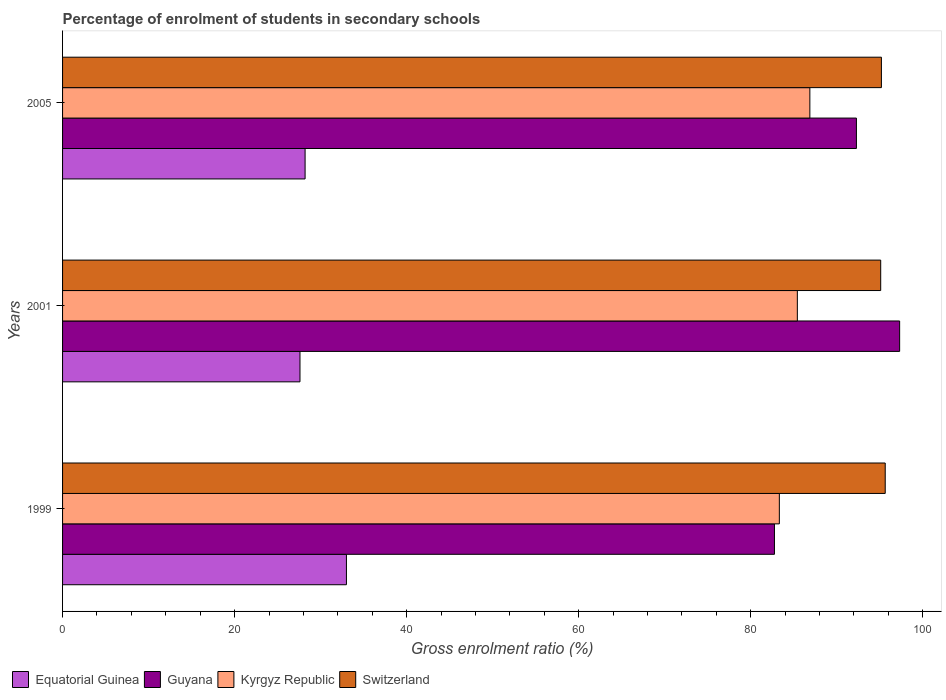How many different coloured bars are there?
Give a very brief answer. 4. Are the number of bars per tick equal to the number of legend labels?
Keep it short and to the point. Yes. Are the number of bars on each tick of the Y-axis equal?
Give a very brief answer. Yes. What is the label of the 1st group of bars from the top?
Ensure brevity in your answer.  2005. What is the percentage of students enrolled in secondary schools in Kyrgyz Republic in 2001?
Your response must be concise. 85.42. Across all years, what is the maximum percentage of students enrolled in secondary schools in Equatorial Guinea?
Offer a very short reply. 33. Across all years, what is the minimum percentage of students enrolled in secondary schools in Switzerland?
Keep it short and to the point. 95.11. In which year was the percentage of students enrolled in secondary schools in Switzerland minimum?
Provide a succinct answer. 2001. What is the total percentage of students enrolled in secondary schools in Guyana in the graph?
Your answer should be compact. 272.35. What is the difference between the percentage of students enrolled in secondary schools in Kyrgyz Republic in 2001 and that in 2005?
Provide a succinct answer. -1.46. What is the difference between the percentage of students enrolled in secondary schools in Switzerland in 2001 and the percentage of students enrolled in secondary schools in Kyrgyz Republic in 1999?
Your answer should be compact. 11.78. What is the average percentage of students enrolled in secondary schools in Switzerland per year?
Offer a very short reply. 95.31. In the year 2005, what is the difference between the percentage of students enrolled in secondary schools in Guyana and percentage of students enrolled in secondary schools in Equatorial Guinea?
Ensure brevity in your answer.  64.09. In how many years, is the percentage of students enrolled in secondary schools in Equatorial Guinea greater than 48 %?
Provide a short and direct response. 0. What is the ratio of the percentage of students enrolled in secondary schools in Equatorial Guinea in 2001 to that in 2005?
Provide a short and direct response. 0.98. Is the percentage of students enrolled in secondary schools in Kyrgyz Republic in 1999 less than that in 2005?
Offer a very short reply. Yes. What is the difference between the highest and the second highest percentage of students enrolled in secondary schools in Kyrgyz Republic?
Keep it short and to the point. 1.46. What is the difference between the highest and the lowest percentage of students enrolled in secondary schools in Switzerland?
Your answer should be compact. 0.53. What does the 3rd bar from the top in 1999 represents?
Provide a short and direct response. Guyana. What does the 2nd bar from the bottom in 2001 represents?
Your response must be concise. Guyana. Is it the case that in every year, the sum of the percentage of students enrolled in secondary schools in Equatorial Guinea and percentage of students enrolled in secondary schools in Guyana is greater than the percentage of students enrolled in secondary schools in Kyrgyz Republic?
Provide a succinct answer. Yes. How many years are there in the graph?
Keep it short and to the point. 3. What is the difference between two consecutive major ticks on the X-axis?
Offer a terse response. 20. Does the graph contain grids?
Your answer should be compact. No. How many legend labels are there?
Offer a very short reply. 4. How are the legend labels stacked?
Offer a terse response. Horizontal. What is the title of the graph?
Ensure brevity in your answer.  Percentage of enrolment of students in secondary schools. Does "Latin America(all income levels)" appear as one of the legend labels in the graph?
Ensure brevity in your answer.  No. What is the label or title of the X-axis?
Your response must be concise. Gross enrolment ratio (%). What is the label or title of the Y-axis?
Give a very brief answer. Years. What is the Gross enrolment ratio (%) of Equatorial Guinea in 1999?
Provide a succinct answer. 33. What is the Gross enrolment ratio (%) of Guyana in 1999?
Provide a succinct answer. 82.76. What is the Gross enrolment ratio (%) of Kyrgyz Republic in 1999?
Offer a very short reply. 83.33. What is the Gross enrolment ratio (%) in Switzerland in 1999?
Make the answer very short. 95.63. What is the Gross enrolment ratio (%) of Equatorial Guinea in 2001?
Provide a short and direct response. 27.6. What is the Gross enrolment ratio (%) in Guyana in 2001?
Provide a short and direct response. 97.31. What is the Gross enrolment ratio (%) in Kyrgyz Republic in 2001?
Offer a very short reply. 85.42. What is the Gross enrolment ratio (%) in Switzerland in 2001?
Offer a terse response. 95.11. What is the Gross enrolment ratio (%) of Equatorial Guinea in 2005?
Make the answer very short. 28.19. What is the Gross enrolment ratio (%) of Guyana in 2005?
Your answer should be very brief. 92.29. What is the Gross enrolment ratio (%) in Kyrgyz Republic in 2005?
Provide a succinct answer. 86.87. What is the Gross enrolment ratio (%) in Switzerland in 2005?
Make the answer very short. 95.19. Across all years, what is the maximum Gross enrolment ratio (%) in Equatorial Guinea?
Keep it short and to the point. 33. Across all years, what is the maximum Gross enrolment ratio (%) in Guyana?
Give a very brief answer. 97.31. Across all years, what is the maximum Gross enrolment ratio (%) in Kyrgyz Republic?
Provide a succinct answer. 86.87. Across all years, what is the maximum Gross enrolment ratio (%) of Switzerland?
Your answer should be very brief. 95.63. Across all years, what is the minimum Gross enrolment ratio (%) in Equatorial Guinea?
Give a very brief answer. 27.6. Across all years, what is the minimum Gross enrolment ratio (%) of Guyana?
Make the answer very short. 82.76. Across all years, what is the minimum Gross enrolment ratio (%) in Kyrgyz Republic?
Offer a terse response. 83.33. Across all years, what is the minimum Gross enrolment ratio (%) in Switzerland?
Offer a terse response. 95.11. What is the total Gross enrolment ratio (%) in Equatorial Guinea in the graph?
Give a very brief answer. 88.79. What is the total Gross enrolment ratio (%) in Guyana in the graph?
Offer a terse response. 272.35. What is the total Gross enrolment ratio (%) of Kyrgyz Republic in the graph?
Your answer should be very brief. 255.62. What is the total Gross enrolment ratio (%) in Switzerland in the graph?
Keep it short and to the point. 285.93. What is the difference between the Gross enrolment ratio (%) of Equatorial Guinea in 1999 and that in 2001?
Ensure brevity in your answer.  5.4. What is the difference between the Gross enrolment ratio (%) in Guyana in 1999 and that in 2001?
Offer a terse response. -14.55. What is the difference between the Gross enrolment ratio (%) of Kyrgyz Republic in 1999 and that in 2001?
Your response must be concise. -2.09. What is the difference between the Gross enrolment ratio (%) of Switzerland in 1999 and that in 2001?
Make the answer very short. 0.53. What is the difference between the Gross enrolment ratio (%) in Equatorial Guinea in 1999 and that in 2005?
Offer a very short reply. 4.81. What is the difference between the Gross enrolment ratio (%) in Guyana in 1999 and that in 2005?
Keep it short and to the point. -9.53. What is the difference between the Gross enrolment ratio (%) of Kyrgyz Republic in 1999 and that in 2005?
Your answer should be very brief. -3.55. What is the difference between the Gross enrolment ratio (%) of Switzerland in 1999 and that in 2005?
Your answer should be compact. 0.44. What is the difference between the Gross enrolment ratio (%) of Equatorial Guinea in 2001 and that in 2005?
Keep it short and to the point. -0.59. What is the difference between the Gross enrolment ratio (%) in Guyana in 2001 and that in 2005?
Your response must be concise. 5.02. What is the difference between the Gross enrolment ratio (%) of Kyrgyz Republic in 2001 and that in 2005?
Provide a succinct answer. -1.46. What is the difference between the Gross enrolment ratio (%) of Switzerland in 2001 and that in 2005?
Keep it short and to the point. -0.08. What is the difference between the Gross enrolment ratio (%) in Equatorial Guinea in 1999 and the Gross enrolment ratio (%) in Guyana in 2001?
Offer a terse response. -64.31. What is the difference between the Gross enrolment ratio (%) of Equatorial Guinea in 1999 and the Gross enrolment ratio (%) of Kyrgyz Republic in 2001?
Offer a terse response. -52.42. What is the difference between the Gross enrolment ratio (%) in Equatorial Guinea in 1999 and the Gross enrolment ratio (%) in Switzerland in 2001?
Your response must be concise. -62.11. What is the difference between the Gross enrolment ratio (%) in Guyana in 1999 and the Gross enrolment ratio (%) in Kyrgyz Republic in 2001?
Provide a short and direct response. -2.66. What is the difference between the Gross enrolment ratio (%) in Guyana in 1999 and the Gross enrolment ratio (%) in Switzerland in 2001?
Make the answer very short. -12.35. What is the difference between the Gross enrolment ratio (%) in Kyrgyz Republic in 1999 and the Gross enrolment ratio (%) in Switzerland in 2001?
Give a very brief answer. -11.78. What is the difference between the Gross enrolment ratio (%) in Equatorial Guinea in 1999 and the Gross enrolment ratio (%) in Guyana in 2005?
Offer a terse response. -59.29. What is the difference between the Gross enrolment ratio (%) in Equatorial Guinea in 1999 and the Gross enrolment ratio (%) in Kyrgyz Republic in 2005?
Give a very brief answer. -53.87. What is the difference between the Gross enrolment ratio (%) of Equatorial Guinea in 1999 and the Gross enrolment ratio (%) of Switzerland in 2005?
Give a very brief answer. -62.19. What is the difference between the Gross enrolment ratio (%) of Guyana in 1999 and the Gross enrolment ratio (%) of Kyrgyz Republic in 2005?
Provide a succinct answer. -4.12. What is the difference between the Gross enrolment ratio (%) of Guyana in 1999 and the Gross enrolment ratio (%) of Switzerland in 2005?
Provide a short and direct response. -12.43. What is the difference between the Gross enrolment ratio (%) of Kyrgyz Republic in 1999 and the Gross enrolment ratio (%) of Switzerland in 2005?
Keep it short and to the point. -11.86. What is the difference between the Gross enrolment ratio (%) in Equatorial Guinea in 2001 and the Gross enrolment ratio (%) in Guyana in 2005?
Provide a succinct answer. -64.69. What is the difference between the Gross enrolment ratio (%) in Equatorial Guinea in 2001 and the Gross enrolment ratio (%) in Kyrgyz Republic in 2005?
Ensure brevity in your answer.  -59.27. What is the difference between the Gross enrolment ratio (%) of Equatorial Guinea in 2001 and the Gross enrolment ratio (%) of Switzerland in 2005?
Make the answer very short. -67.59. What is the difference between the Gross enrolment ratio (%) in Guyana in 2001 and the Gross enrolment ratio (%) in Kyrgyz Republic in 2005?
Provide a short and direct response. 10.44. What is the difference between the Gross enrolment ratio (%) in Guyana in 2001 and the Gross enrolment ratio (%) in Switzerland in 2005?
Give a very brief answer. 2.12. What is the difference between the Gross enrolment ratio (%) in Kyrgyz Republic in 2001 and the Gross enrolment ratio (%) in Switzerland in 2005?
Offer a terse response. -9.77. What is the average Gross enrolment ratio (%) in Equatorial Guinea per year?
Keep it short and to the point. 29.6. What is the average Gross enrolment ratio (%) in Guyana per year?
Keep it short and to the point. 90.78. What is the average Gross enrolment ratio (%) of Kyrgyz Republic per year?
Your response must be concise. 85.21. What is the average Gross enrolment ratio (%) of Switzerland per year?
Offer a very short reply. 95.31. In the year 1999, what is the difference between the Gross enrolment ratio (%) of Equatorial Guinea and Gross enrolment ratio (%) of Guyana?
Ensure brevity in your answer.  -49.76. In the year 1999, what is the difference between the Gross enrolment ratio (%) of Equatorial Guinea and Gross enrolment ratio (%) of Kyrgyz Republic?
Make the answer very short. -50.33. In the year 1999, what is the difference between the Gross enrolment ratio (%) of Equatorial Guinea and Gross enrolment ratio (%) of Switzerland?
Your response must be concise. -62.63. In the year 1999, what is the difference between the Gross enrolment ratio (%) in Guyana and Gross enrolment ratio (%) in Kyrgyz Republic?
Provide a succinct answer. -0.57. In the year 1999, what is the difference between the Gross enrolment ratio (%) of Guyana and Gross enrolment ratio (%) of Switzerland?
Your answer should be compact. -12.88. In the year 1999, what is the difference between the Gross enrolment ratio (%) in Kyrgyz Republic and Gross enrolment ratio (%) in Switzerland?
Make the answer very short. -12.31. In the year 2001, what is the difference between the Gross enrolment ratio (%) in Equatorial Guinea and Gross enrolment ratio (%) in Guyana?
Keep it short and to the point. -69.71. In the year 2001, what is the difference between the Gross enrolment ratio (%) of Equatorial Guinea and Gross enrolment ratio (%) of Kyrgyz Republic?
Your response must be concise. -57.82. In the year 2001, what is the difference between the Gross enrolment ratio (%) of Equatorial Guinea and Gross enrolment ratio (%) of Switzerland?
Your answer should be very brief. -67.51. In the year 2001, what is the difference between the Gross enrolment ratio (%) of Guyana and Gross enrolment ratio (%) of Kyrgyz Republic?
Keep it short and to the point. 11.89. In the year 2001, what is the difference between the Gross enrolment ratio (%) in Guyana and Gross enrolment ratio (%) in Switzerland?
Ensure brevity in your answer.  2.2. In the year 2001, what is the difference between the Gross enrolment ratio (%) in Kyrgyz Republic and Gross enrolment ratio (%) in Switzerland?
Give a very brief answer. -9.69. In the year 2005, what is the difference between the Gross enrolment ratio (%) of Equatorial Guinea and Gross enrolment ratio (%) of Guyana?
Provide a short and direct response. -64.09. In the year 2005, what is the difference between the Gross enrolment ratio (%) of Equatorial Guinea and Gross enrolment ratio (%) of Kyrgyz Republic?
Offer a terse response. -58.68. In the year 2005, what is the difference between the Gross enrolment ratio (%) in Equatorial Guinea and Gross enrolment ratio (%) in Switzerland?
Provide a succinct answer. -67. In the year 2005, what is the difference between the Gross enrolment ratio (%) of Guyana and Gross enrolment ratio (%) of Kyrgyz Republic?
Offer a very short reply. 5.41. In the year 2005, what is the difference between the Gross enrolment ratio (%) of Guyana and Gross enrolment ratio (%) of Switzerland?
Your answer should be compact. -2.9. In the year 2005, what is the difference between the Gross enrolment ratio (%) in Kyrgyz Republic and Gross enrolment ratio (%) in Switzerland?
Make the answer very short. -8.32. What is the ratio of the Gross enrolment ratio (%) of Equatorial Guinea in 1999 to that in 2001?
Provide a succinct answer. 1.2. What is the ratio of the Gross enrolment ratio (%) in Guyana in 1999 to that in 2001?
Give a very brief answer. 0.85. What is the ratio of the Gross enrolment ratio (%) in Kyrgyz Republic in 1999 to that in 2001?
Your response must be concise. 0.98. What is the ratio of the Gross enrolment ratio (%) of Equatorial Guinea in 1999 to that in 2005?
Your answer should be very brief. 1.17. What is the ratio of the Gross enrolment ratio (%) of Guyana in 1999 to that in 2005?
Keep it short and to the point. 0.9. What is the ratio of the Gross enrolment ratio (%) of Kyrgyz Republic in 1999 to that in 2005?
Your answer should be very brief. 0.96. What is the ratio of the Gross enrolment ratio (%) of Equatorial Guinea in 2001 to that in 2005?
Offer a very short reply. 0.98. What is the ratio of the Gross enrolment ratio (%) in Guyana in 2001 to that in 2005?
Your answer should be very brief. 1.05. What is the ratio of the Gross enrolment ratio (%) of Kyrgyz Republic in 2001 to that in 2005?
Make the answer very short. 0.98. What is the difference between the highest and the second highest Gross enrolment ratio (%) of Equatorial Guinea?
Offer a very short reply. 4.81. What is the difference between the highest and the second highest Gross enrolment ratio (%) in Guyana?
Your response must be concise. 5.02. What is the difference between the highest and the second highest Gross enrolment ratio (%) in Kyrgyz Republic?
Provide a succinct answer. 1.46. What is the difference between the highest and the second highest Gross enrolment ratio (%) of Switzerland?
Ensure brevity in your answer.  0.44. What is the difference between the highest and the lowest Gross enrolment ratio (%) of Equatorial Guinea?
Offer a very short reply. 5.4. What is the difference between the highest and the lowest Gross enrolment ratio (%) in Guyana?
Offer a terse response. 14.55. What is the difference between the highest and the lowest Gross enrolment ratio (%) of Kyrgyz Republic?
Your answer should be compact. 3.55. What is the difference between the highest and the lowest Gross enrolment ratio (%) in Switzerland?
Offer a terse response. 0.53. 